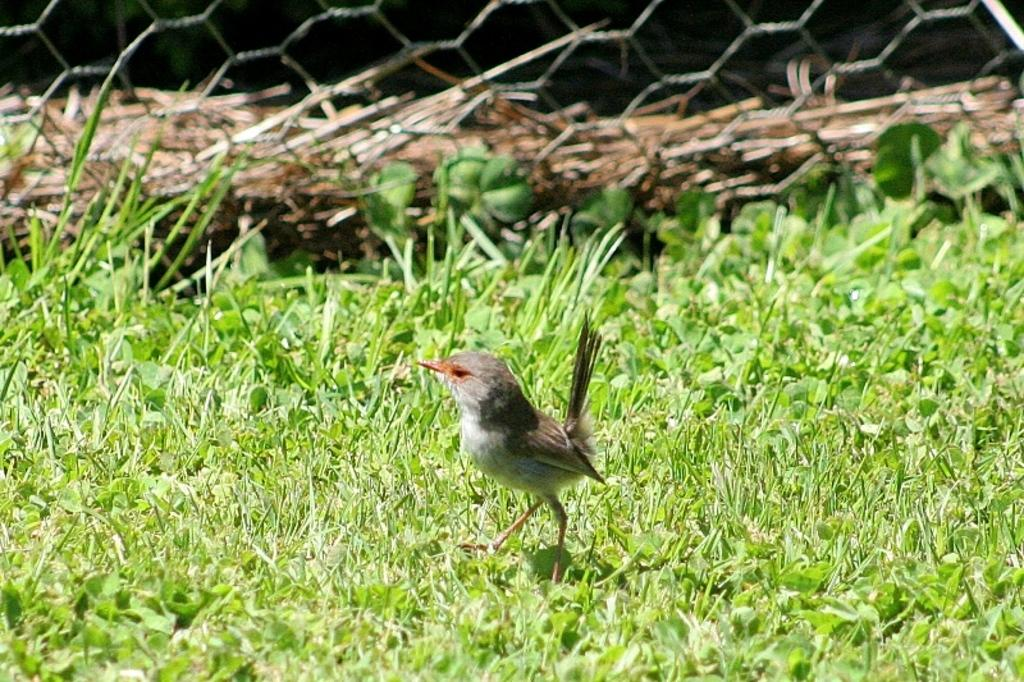What is on the ground in the image? There is a bird on the ground in the image. What is the color of the grass on the ground? The ground has green color grass. What can be seen in the background of the image? There is a net and a trunk in the background. What type of jeans is the bird wearing in the image? There are no jeans present in the image, as birds do not wear clothing. 